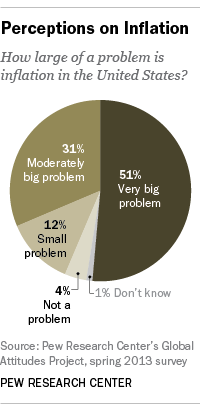Specify some key components in this picture. The most popular opinion is a very big problem. According to a survey, 82% of people believe that it is a significant issue. 